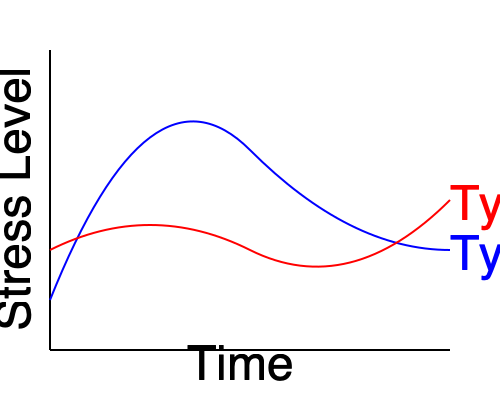During your commute, you discuss stress management with a coworker. You show them this graph representing stress-response curves for different personality types over time. Which personality type is likely to experience a more prolonged stress response, and why might this be significant in a workplace setting? To answer this question, let's analyze the graph step-by-step:

1. The graph shows two curves: blue (Type A) and red (Type B).

2. The x-axis represents time, and the y-axis represents stress level.

3. Type A personality (blue curve):
   - Starts with a higher initial stress level
   - Quickly reaches a high peak stress level
   - Gradually decreases over time, but remains at a higher level compared to Type B

4. Type B personality (red curve):
   - Starts with a lower initial stress level
   - Reaches a lower peak stress level compared to Type A
   - Decreases more quickly and settles at a lower stress level

5. Comparing the two curves, we can see that the Type A personality experiences a more prolonged stress response. The blue curve remains higher for a longer period and doesn't return to baseline as quickly as the red curve.

6. In a workplace setting, this prolonged stress response for Type A personalities could be significant because:
   - It may lead to chronic stress and potential burnout
   - It could affect decision-making and interpersonal relationships
   - It might result in health issues due to sustained high stress levels
   - It could impact overall productivity and job satisfaction

7. Understanding these differences can help in developing personalized stress management strategies and creating a more supportive work environment that accommodates different personality types.
Answer: Type A; prolonged stress may lead to burnout and decreased productivity. 